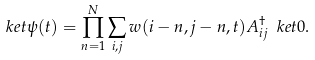<formula> <loc_0><loc_0><loc_500><loc_500>\ k e t { \psi ( t ) } = \prod _ { n = 1 } ^ { N } \sum _ { i , j } w ( i - n , j - n , t ) A _ { i j } ^ { \dagger } \ k e t { 0 } .</formula> 